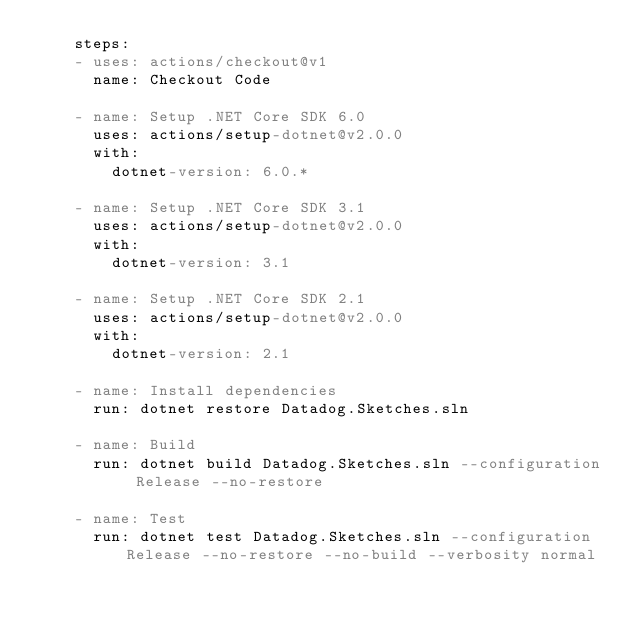<code> <loc_0><loc_0><loc_500><loc_500><_YAML_>    steps:
    - uses: actions/checkout@v1
      name: Checkout Code      

    - name: Setup .NET Core SDK 6.0
      uses: actions/setup-dotnet@v2.0.0
      with:
        dotnet-version: 6.0.*

    - name: Setup .NET Core SDK 3.1
      uses: actions/setup-dotnet@v2.0.0
      with:
        dotnet-version: 3.1
        
    - name: Setup .NET Core SDK 2.1
      uses: actions/setup-dotnet@v2.0.0
      with:
        dotnet-version: 2.1

    - name: Install dependencies
      run: dotnet restore Datadog.Sketches.sln

    - name: Build
      run: dotnet build Datadog.Sketches.sln --configuration Release --no-restore

    - name: Test
      run: dotnet test Datadog.Sketches.sln --configuration Release --no-restore --no-build --verbosity normal
 
</code> 